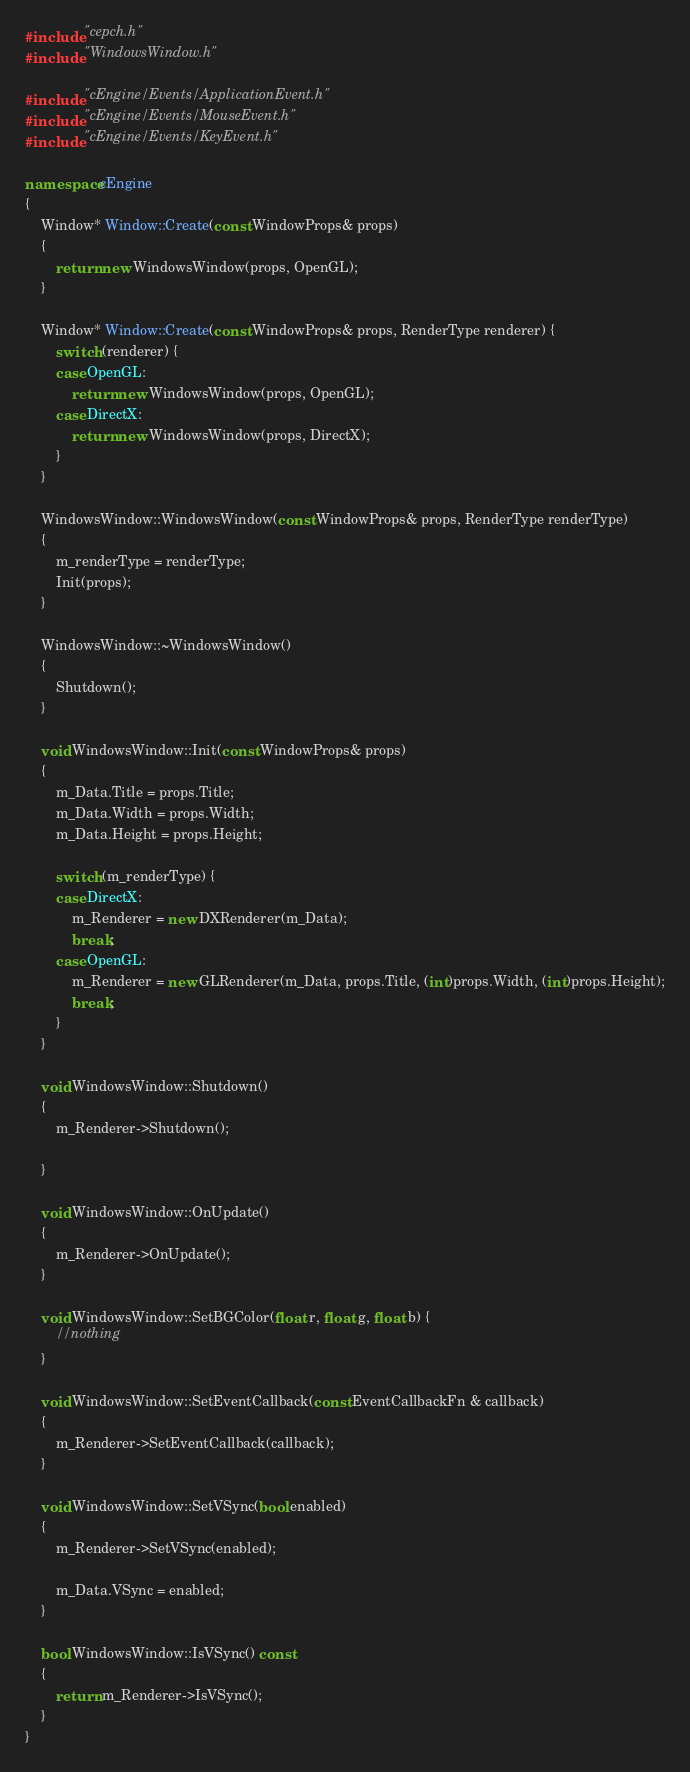<code> <loc_0><loc_0><loc_500><loc_500><_C++_>#include "cepch.h"
#include "WindowsWindow.h"

#include "cEngine/Events/ApplicationEvent.h"
#include "cEngine/Events/MouseEvent.h"
#include "cEngine/Events/KeyEvent.h"

namespace cEngine
{
	Window* Window::Create(const WindowProps& props)
	{
		return new WindowsWindow(props, OpenGL);
	}

	Window* Window::Create(const WindowProps& props, RenderType renderer) {
		switch (renderer) {
		case OpenGL:
			return new WindowsWindow(props, OpenGL);
		case DirectX:
			return new WindowsWindow(props, DirectX);
		}
	}

	WindowsWindow::WindowsWindow(const WindowProps& props, RenderType renderType)
	{
		m_renderType = renderType;
		Init(props);
	}

	WindowsWindow::~WindowsWindow()
	{
		Shutdown();
	}

	void WindowsWindow::Init(const WindowProps& props)
	{
		m_Data.Title = props.Title;
		m_Data.Width = props.Width;
		m_Data.Height = props.Height;

		switch (m_renderType) {
		case DirectX:
			m_Renderer = new DXRenderer(m_Data);
			break;
		case OpenGL:
			m_Renderer = new GLRenderer(m_Data, props.Title, (int)props.Width, (int)props.Height);
			break;
		}
	}

	void WindowsWindow::Shutdown()
	{
		m_Renderer->Shutdown();
		
	}

	void WindowsWindow::OnUpdate()
	{
		m_Renderer->OnUpdate();
	}

	void WindowsWindow::SetBGColor(float r, float g, float b) {
		//nothing
	}

	void WindowsWindow::SetEventCallback(const EventCallbackFn & callback)
	{
		m_Renderer->SetEventCallback(callback);
	}

	void WindowsWindow::SetVSync(bool enabled)
	{
		m_Renderer->SetVSync(enabled);

		m_Data.VSync = enabled;
	}

	bool WindowsWindow::IsVSync() const
	{
		return m_Renderer->IsVSync();
	}
}</code> 